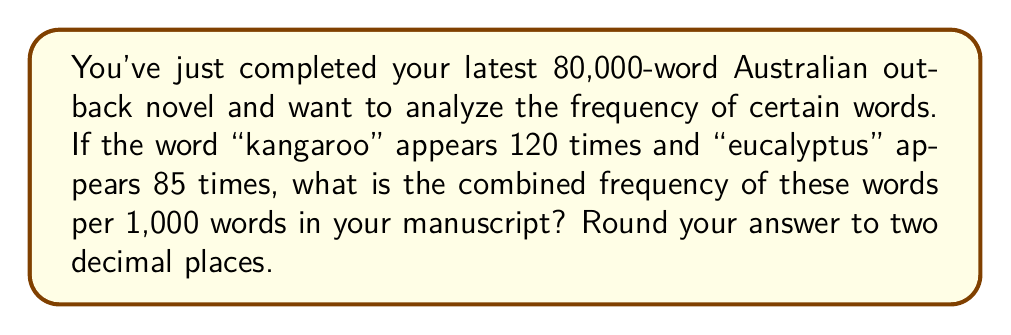Provide a solution to this math problem. To solve this problem, we need to follow these steps:

1. Calculate the total number of occurrences of both words:
   $120 + 85 = 205$ occurrences

2. Set up the frequency ratio:
   Let $x$ be the frequency per 1,000 words.
   $$\frac{205\text{ occurrences}}{80,000\text{ words}} = \frac{x\text{ occurrences}}{1,000\text{ words}}$$

3. Cross multiply:
   $$205 \cdot 1,000 = 80,000x$$

4. Solve for $x$:
   $$x = \frac{205,000}{80,000} = 2.5625$$

5. Round to two decimal places:
   $2.56$

Therefore, the combined frequency of "kangaroo" and "eucalyptus" is 2.56 occurrences per 1,000 words in your manuscript.
Answer: 2.56 occurrences per 1,000 words 